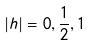Convert formula to latex. <formula><loc_0><loc_0><loc_500><loc_500>| h | = 0 , \frac { 1 } { 2 } , 1</formula> 